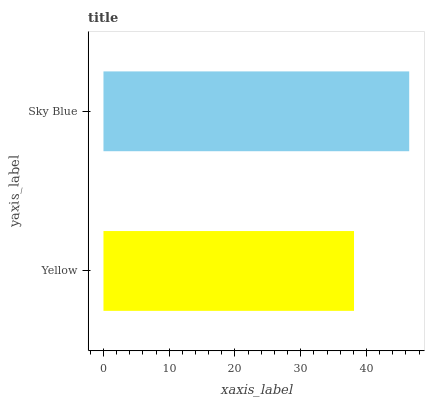Is Yellow the minimum?
Answer yes or no. Yes. Is Sky Blue the maximum?
Answer yes or no. Yes. Is Sky Blue the minimum?
Answer yes or no. No. Is Sky Blue greater than Yellow?
Answer yes or no. Yes. Is Yellow less than Sky Blue?
Answer yes or no. Yes. Is Yellow greater than Sky Blue?
Answer yes or no. No. Is Sky Blue less than Yellow?
Answer yes or no. No. Is Sky Blue the high median?
Answer yes or no. Yes. Is Yellow the low median?
Answer yes or no. Yes. Is Yellow the high median?
Answer yes or no. No. Is Sky Blue the low median?
Answer yes or no. No. 